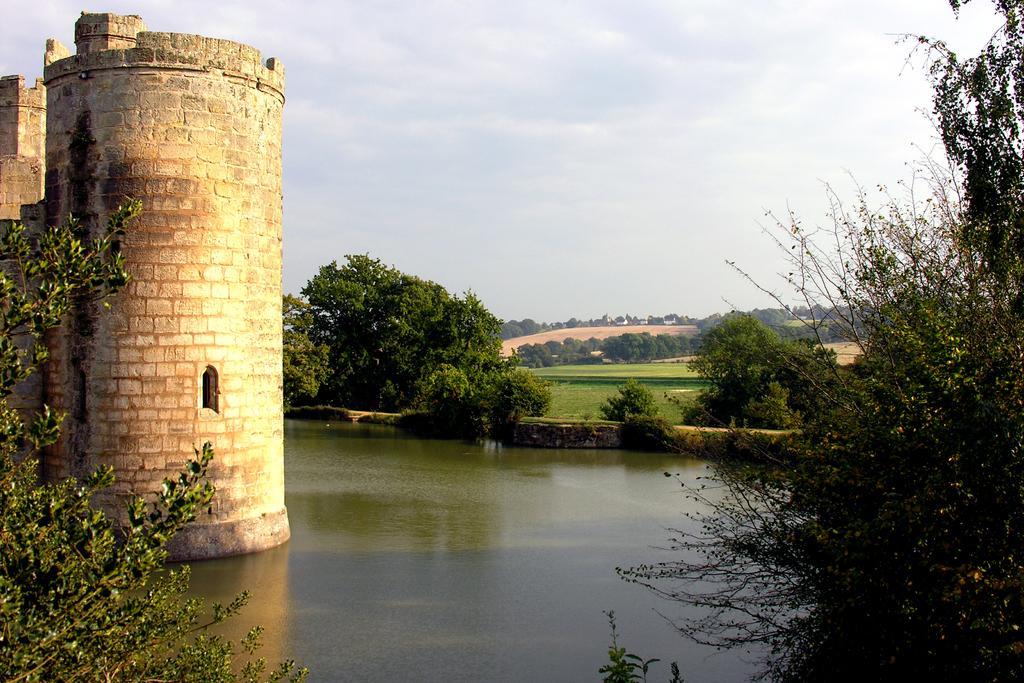In one or two sentences, can you explain what this image depicts? In this image I can see the water. To the side of the water I can see many trees and the fort. In the background I can see few more trees, clouds and the sky. 